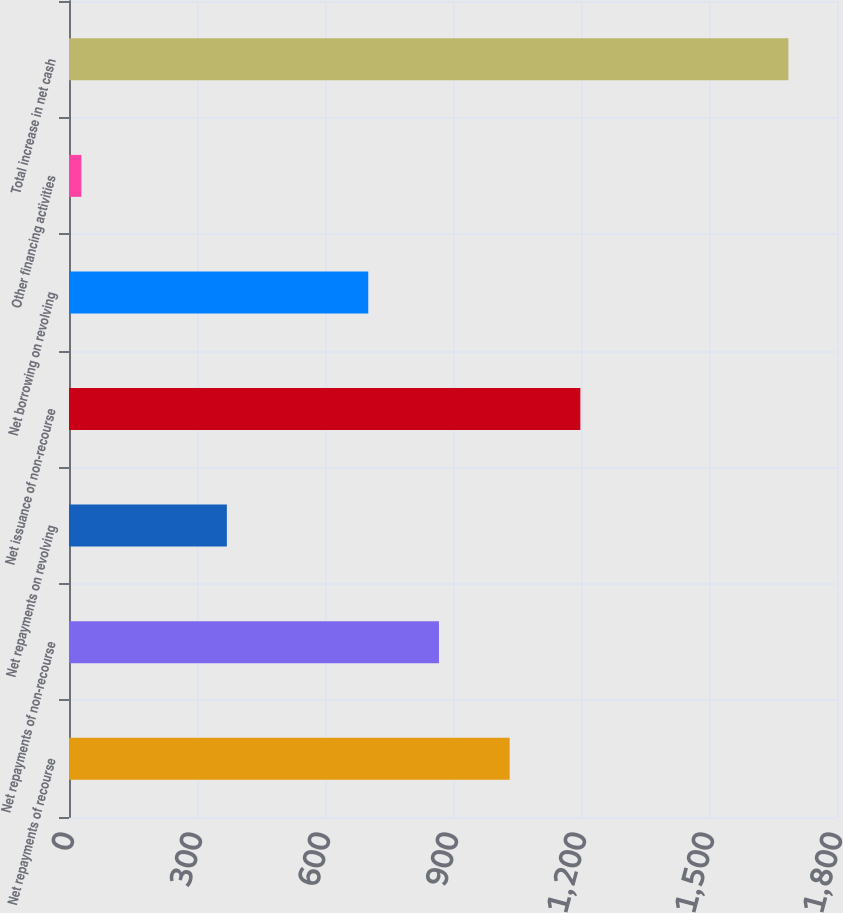Convert chart to OTSL. <chart><loc_0><loc_0><loc_500><loc_500><bar_chart><fcel>Net repayments of recourse<fcel>Net repayments of non-recourse<fcel>Net repayments on revolving<fcel>Net issuance of non-recourse<fcel>Net borrowing on revolving<fcel>Other financing activities<fcel>Total increase in net cash<nl><fcel>1032.8<fcel>867.1<fcel>370<fcel>1198.5<fcel>701.4<fcel>29<fcel>1686<nl></chart> 